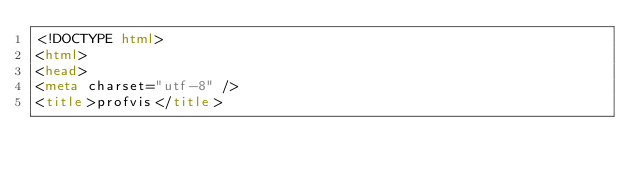<code> <loc_0><loc_0><loc_500><loc_500><_HTML_><!DOCTYPE html>
<html>
<head>
<meta charset="utf-8" />
<title>profvis</title></code> 